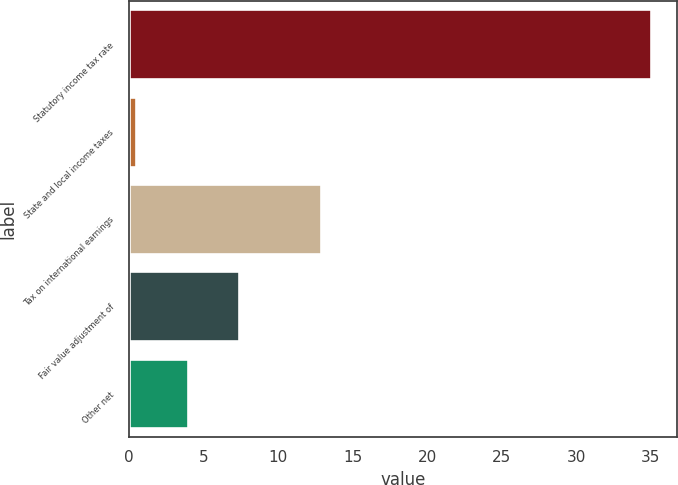Convert chart to OTSL. <chart><loc_0><loc_0><loc_500><loc_500><bar_chart><fcel>Statutory income tax rate<fcel>State and local income taxes<fcel>Tax on international earnings<fcel>Fair value adjustment of<fcel>Other net<nl><fcel>35<fcel>0.5<fcel>12.9<fcel>7.4<fcel>3.95<nl></chart> 